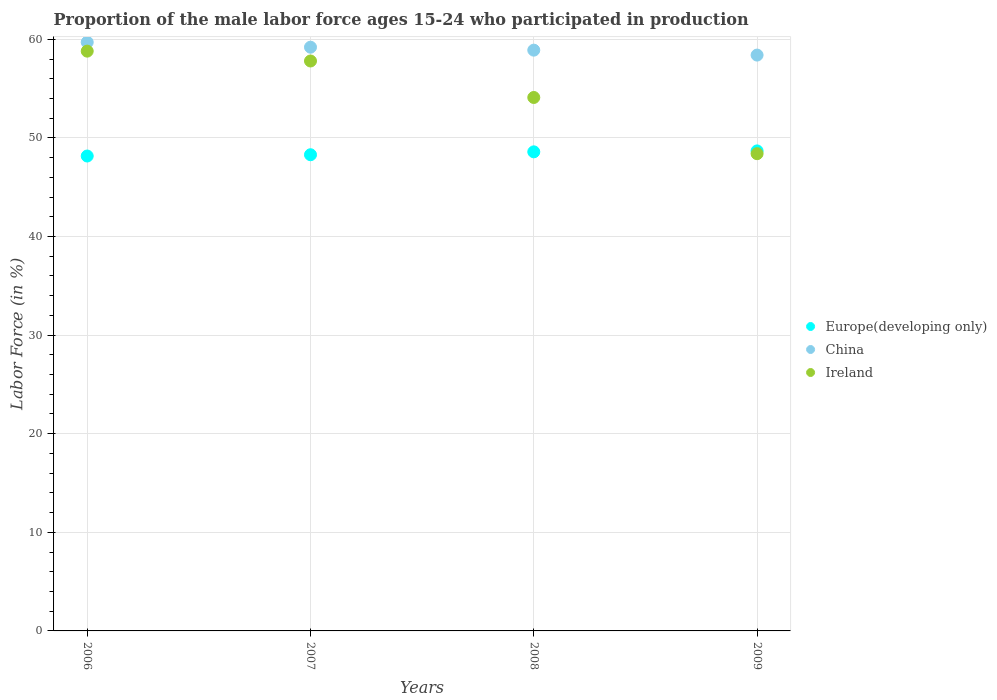What is the proportion of the male labor force who participated in production in China in 2006?
Keep it short and to the point. 59.7. Across all years, what is the maximum proportion of the male labor force who participated in production in Europe(developing only)?
Your answer should be very brief. 48.68. Across all years, what is the minimum proportion of the male labor force who participated in production in China?
Give a very brief answer. 58.4. In which year was the proportion of the male labor force who participated in production in Ireland minimum?
Provide a succinct answer. 2009. What is the total proportion of the male labor force who participated in production in Europe(developing only) in the graph?
Your answer should be compact. 193.72. What is the difference between the proportion of the male labor force who participated in production in China in 2006 and that in 2009?
Provide a short and direct response. 1.3. What is the difference between the proportion of the male labor force who participated in production in Europe(developing only) in 2006 and the proportion of the male labor force who participated in production in China in 2008?
Your answer should be very brief. -10.74. What is the average proportion of the male labor force who participated in production in Ireland per year?
Your response must be concise. 54.77. In the year 2008, what is the difference between the proportion of the male labor force who participated in production in Europe(developing only) and proportion of the male labor force who participated in production in China?
Provide a succinct answer. -10.31. What is the ratio of the proportion of the male labor force who participated in production in Europe(developing only) in 2008 to that in 2009?
Your response must be concise. 1. Is the difference between the proportion of the male labor force who participated in production in Europe(developing only) in 2007 and 2008 greater than the difference between the proportion of the male labor force who participated in production in China in 2007 and 2008?
Your answer should be compact. No. What is the difference between the highest and the lowest proportion of the male labor force who participated in production in Ireland?
Your answer should be compact. 10.4. Is the sum of the proportion of the male labor force who participated in production in Ireland in 2007 and 2008 greater than the maximum proportion of the male labor force who participated in production in China across all years?
Your answer should be compact. Yes. What is the difference between two consecutive major ticks on the Y-axis?
Your answer should be very brief. 10. Where does the legend appear in the graph?
Make the answer very short. Center right. What is the title of the graph?
Offer a very short reply. Proportion of the male labor force ages 15-24 who participated in production. What is the label or title of the X-axis?
Keep it short and to the point. Years. What is the Labor Force (in %) of Europe(developing only) in 2006?
Make the answer very short. 48.16. What is the Labor Force (in %) in China in 2006?
Offer a very short reply. 59.7. What is the Labor Force (in %) of Ireland in 2006?
Your answer should be compact. 58.8. What is the Labor Force (in %) of Europe(developing only) in 2007?
Provide a short and direct response. 48.29. What is the Labor Force (in %) in China in 2007?
Ensure brevity in your answer.  59.2. What is the Labor Force (in %) of Ireland in 2007?
Your answer should be compact. 57.8. What is the Labor Force (in %) of Europe(developing only) in 2008?
Offer a very short reply. 48.59. What is the Labor Force (in %) of China in 2008?
Make the answer very short. 58.9. What is the Labor Force (in %) in Ireland in 2008?
Make the answer very short. 54.1. What is the Labor Force (in %) in Europe(developing only) in 2009?
Ensure brevity in your answer.  48.68. What is the Labor Force (in %) of China in 2009?
Keep it short and to the point. 58.4. What is the Labor Force (in %) of Ireland in 2009?
Your answer should be compact. 48.4. Across all years, what is the maximum Labor Force (in %) in Europe(developing only)?
Ensure brevity in your answer.  48.68. Across all years, what is the maximum Labor Force (in %) of China?
Your response must be concise. 59.7. Across all years, what is the maximum Labor Force (in %) in Ireland?
Make the answer very short. 58.8. Across all years, what is the minimum Labor Force (in %) in Europe(developing only)?
Your answer should be very brief. 48.16. Across all years, what is the minimum Labor Force (in %) in China?
Provide a succinct answer. 58.4. Across all years, what is the minimum Labor Force (in %) in Ireland?
Ensure brevity in your answer.  48.4. What is the total Labor Force (in %) in Europe(developing only) in the graph?
Offer a very short reply. 193.72. What is the total Labor Force (in %) in China in the graph?
Your answer should be very brief. 236.2. What is the total Labor Force (in %) of Ireland in the graph?
Give a very brief answer. 219.1. What is the difference between the Labor Force (in %) in Europe(developing only) in 2006 and that in 2007?
Your answer should be very brief. -0.13. What is the difference between the Labor Force (in %) of China in 2006 and that in 2007?
Keep it short and to the point. 0.5. What is the difference between the Labor Force (in %) in Ireland in 2006 and that in 2007?
Your response must be concise. 1. What is the difference between the Labor Force (in %) in Europe(developing only) in 2006 and that in 2008?
Provide a succinct answer. -0.42. What is the difference between the Labor Force (in %) in Ireland in 2006 and that in 2008?
Ensure brevity in your answer.  4.7. What is the difference between the Labor Force (in %) of Europe(developing only) in 2006 and that in 2009?
Give a very brief answer. -0.52. What is the difference between the Labor Force (in %) of China in 2006 and that in 2009?
Ensure brevity in your answer.  1.3. What is the difference between the Labor Force (in %) in Ireland in 2006 and that in 2009?
Provide a short and direct response. 10.4. What is the difference between the Labor Force (in %) of Europe(developing only) in 2007 and that in 2008?
Your answer should be compact. -0.29. What is the difference between the Labor Force (in %) of Europe(developing only) in 2007 and that in 2009?
Provide a short and direct response. -0.39. What is the difference between the Labor Force (in %) in China in 2007 and that in 2009?
Keep it short and to the point. 0.8. What is the difference between the Labor Force (in %) of Ireland in 2007 and that in 2009?
Ensure brevity in your answer.  9.4. What is the difference between the Labor Force (in %) of Europe(developing only) in 2008 and that in 2009?
Your answer should be compact. -0.09. What is the difference between the Labor Force (in %) of Europe(developing only) in 2006 and the Labor Force (in %) of China in 2007?
Offer a terse response. -11.04. What is the difference between the Labor Force (in %) in Europe(developing only) in 2006 and the Labor Force (in %) in Ireland in 2007?
Provide a succinct answer. -9.64. What is the difference between the Labor Force (in %) of China in 2006 and the Labor Force (in %) of Ireland in 2007?
Your response must be concise. 1.9. What is the difference between the Labor Force (in %) of Europe(developing only) in 2006 and the Labor Force (in %) of China in 2008?
Your response must be concise. -10.74. What is the difference between the Labor Force (in %) in Europe(developing only) in 2006 and the Labor Force (in %) in Ireland in 2008?
Offer a terse response. -5.94. What is the difference between the Labor Force (in %) of China in 2006 and the Labor Force (in %) of Ireland in 2008?
Offer a very short reply. 5.6. What is the difference between the Labor Force (in %) of Europe(developing only) in 2006 and the Labor Force (in %) of China in 2009?
Your answer should be compact. -10.24. What is the difference between the Labor Force (in %) in Europe(developing only) in 2006 and the Labor Force (in %) in Ireland in 2009?
Keep it short and to the point. -0.24. What is the difference between the Labor Force (in %) in China in 2006 and the Labor Force (in %) in Ireland in 2009?
Ensure brevity in your answer.  11.3. What is the difference between the Labor Force (in %) in Europe(developing only) in 2007 and the Labor Force (in %) in China in 2008?
Make the answer very short. -10.61. What is the difference between the Labor Force (in %) in Europe(developing only) in 2007 and the Labor Force (in %) in Ireland in 2008?
Ensure brevity in your answer.  -5.81. What is the difference between the Labor Force (in %) of China in 2007 and the Labor Force (in %) of Ireland in 2008?
Offer a terse response. 5.1. What is the difference between the Labor Force (in %) of Europe(developing only) in 2007 and the Labor Force (in %) of China in 2009?
Give a very brief answer. -10.11. What is the difference between the Labor Force (in %) of Europe(developing only) in 2007 and the Labor Force (in %) of Ireland in 2009?
Your answer should be compact. -0.11. What is the difference between the Labor Force (in %) in China in 2007 and the Labor Force (in %) in Ireland in 2009?
Make the answer very short. 10.8. What is the difference between the Labor Force (in %) in Europe(developing only) in 2008 and the Labor Force (in %) in China in 2009?
Make the answer very short. -9.81. What is the difference between the Labor Force (in %) of Europe(developing only) in 2008 and the Labor Force (in %) of Ireland in 2009?
Provide a short and direct response. 0.19. What is the difference between the Labor Force (in %) of China in 2008 and the Labor Force (in %) of Ireland in 2009?
Give a very brief answer. 10.5. What is the average Labor Force (in %) of Europe(developing only) per year?
Ensure brevity in your answer.  48.43. What is the average Labor Force (in %) of China per year?
Make the answer very short. 59.05. What is the average Labor Force (in %) in Ireland per year?
Give a very brief answer. 54.77. In the year 2006, what is the difference between the Labor Force (in %) in Europe(developing only) and Labor Force (in %) in China?
Offer a very short reply. -11.54. In the year 2006, what is the difference between the Labor Force (in %) in Europe(developing only) and Labor Force (in %) in Ireland?
Give a very brief answer. -10.64. In the year 2007, what is the difference between the Labor Force (in %) of Europe(developing only) and Labor Force (in %) of China?
Your response must be concise. -10.91. In the year 2007, what is the difference between the Labor Force (in %) in Europe(developing only) and Labor Force (in %) in Ireland?
Keep it short and to the point. -9.51. In the year 2008, what is the difference between the Labor Force (in %) of Europe(developing only) and Labor Force (in %) of China?
Ensure brevity in your answer.  -10.31. In the year 2008, what is the difference between the Labor Force (in %) in Europe(developing only) and Labor Force (in %) in Ireland?
Keep it short and to the point. -5.51. In the year 2008, what is the difference between the Labor Force (in %) in China and Labor Force (in %) in Ireland?
Provide a short and direct response. 4.8. In the year 2009, what is the difference between the Labor Force (in %) of Europe(developing only) and Labor Force (in %) of China?
Offer a terse response. -9.72. In the year 2009, what is the difference between the Labor Force (in %) of Europe(developing only) and Labor Force (in %) of Ireland?
Give a very brief answer. 0.28. In the year 2009, what is the difference between the Labor Force (in %) of China and Labor Force (in %) of Ireland?
Offer a terse response. 10. What is the ratio of the Labor Force (in %) in China in 2006 to that in 2007?
Ensure brevity in your answer.  1.01. What is the ratio of the Labor Force (in %) in Ireland in 2006 to that in 2007?
Ensure brevity in your answer.  1.02. What is the ratio of the Labor Force (in %) in China in 2006 to that in 2008?
Provide a succinct answer. 1.01. What is the ratio of the Labor Force (in %) of Ireland in 2006 to that in 2008?
Offer a very short reply. 1.09. What is the ratio of the Labor Force (in %) in Europe(developing only) in 2006 to that in 2009?
Give a very brief answer. 0.99. What is the ratio of the Labor Force (in %) in China in 2006 to that in 2009?
Give a very brief answer. 1.02. What is the ratio of the Labor Force (in %) of Ireland in 2006 to that in 2009?
Provide a short and direct response. 1.21. What is the ratio of the Labor Force (in %) in Europe(developing only) in 2007 to that in 2008?
Provide a succinct answer. 0.99. What is the ratio of the Labor Force (in %) in China in 2007 to that in 2008?
Offer a terse response. 1.01. What is the ratio of the Labor Force (in %) in Ireland in 2007 to that in 2008?
Keep it short and to the point. 1.07. What is the ratio of the Labor Force (in %) in China in 2007 to that in 2009?
Make the answer very short. 1.01. What is the ratio of the Labor Force (in %) in Ireland in 2007 to that in 2009?
Offer a terse response. 1.19. What is the ratio of the Labor Force (in %) of China in 2008 to that in 2009?
Provide a short and direct response. 1.01. What is the ratio of the Labor Force (in %) of Ireland in 2008 to that in 2009?
Offer a very short reply. 1.12. What is the difference between the highest and the second highest Labor Force (in %) of Europe(developing only)?
Offer a very short reply. 0.09. What is the difference between the highest and the second highest Labor Force (in %) of Ireland?
Your answer should be very brief. 1. What is the difference between the highest and the lowest Labor Force (in %) of Europe(developing only)?
Your response must be concise. 0.52. What is the difference between the highest and the lowest Labor Force (in %) of China?
Offer a very short reply. 1.3. What is the difference between the highest and the lowest Labor Force (in %) in Ireland?
Your answer should be compact. 10.4. 